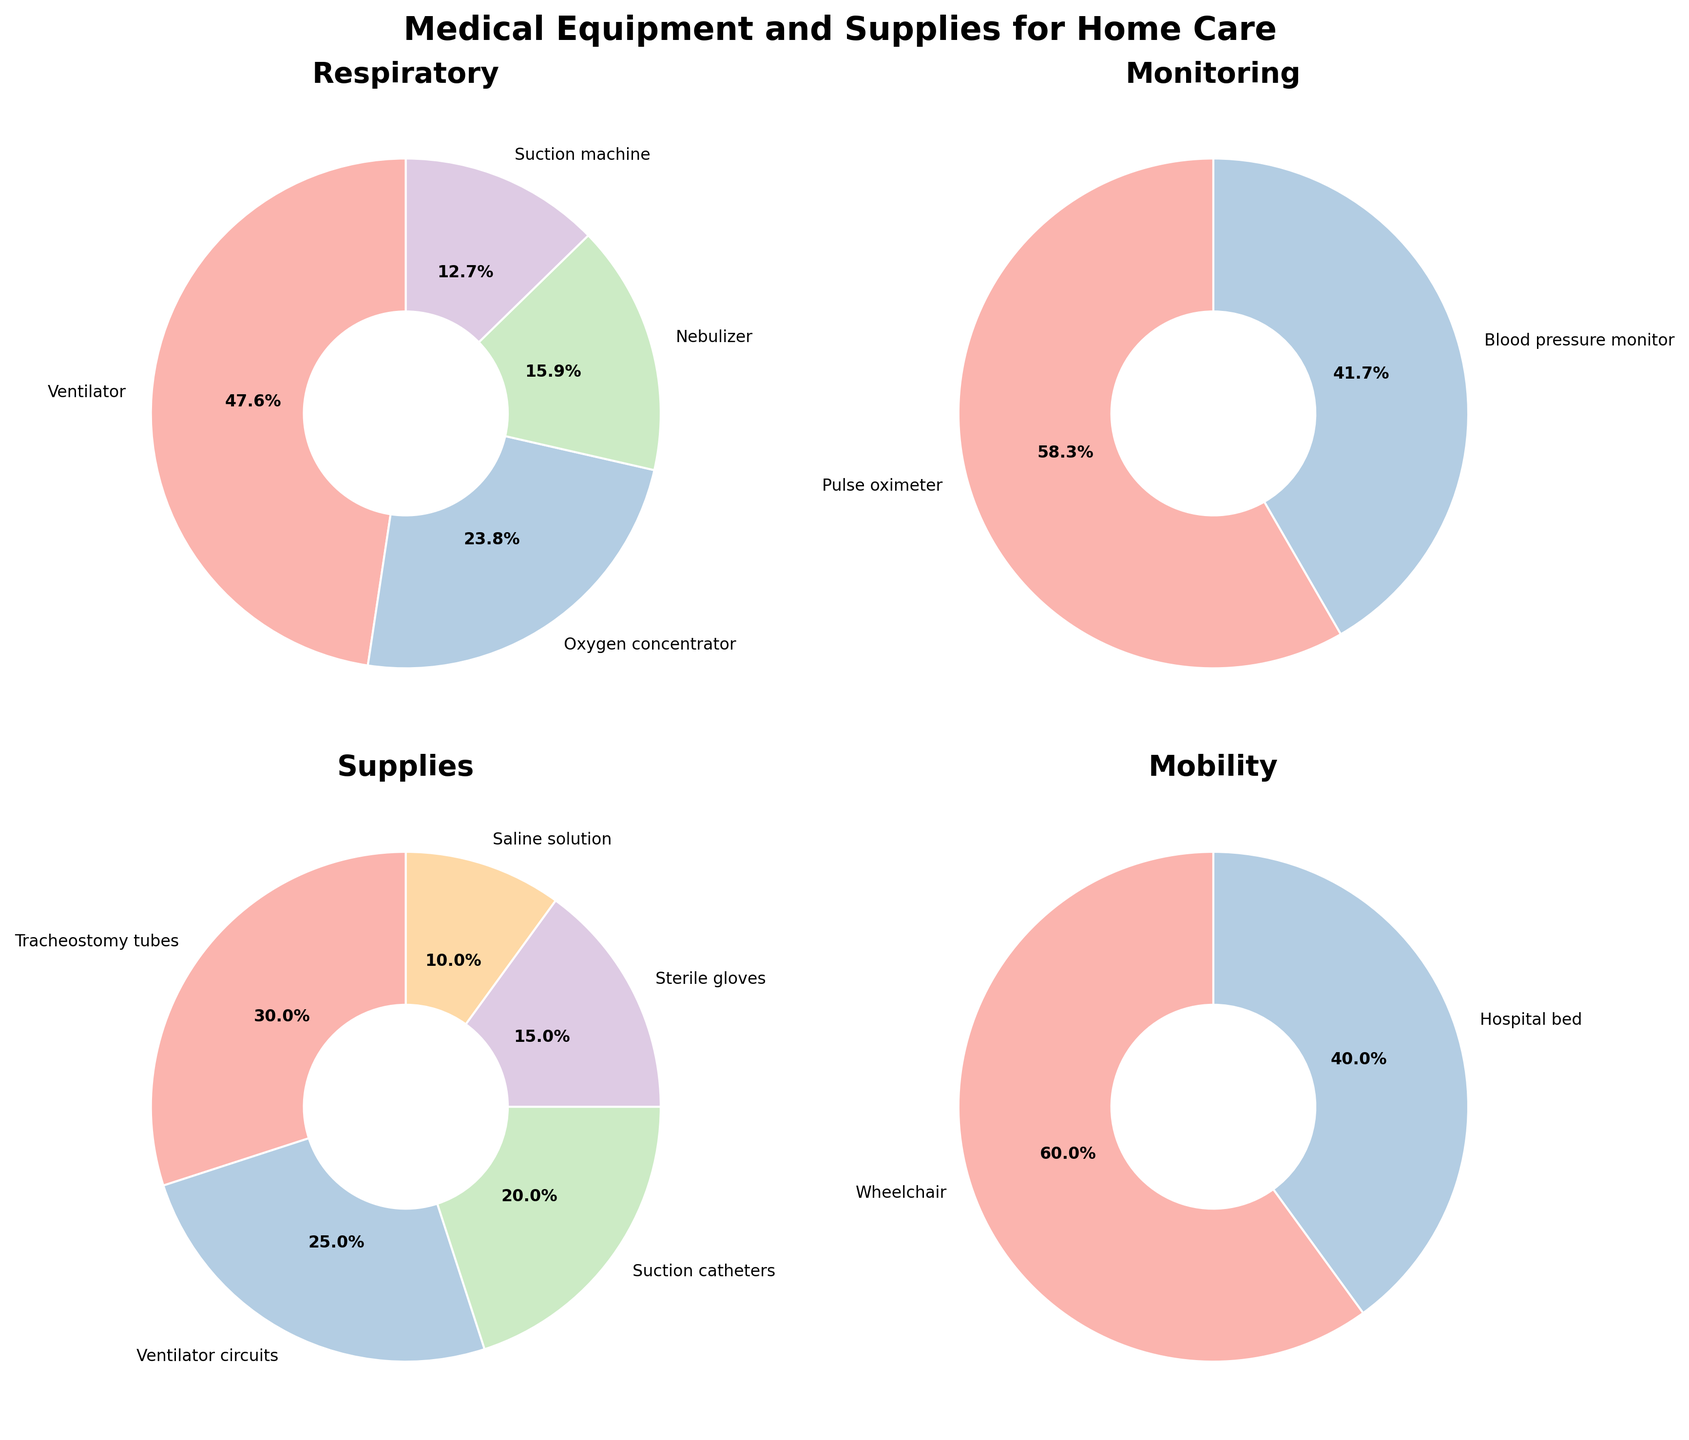What is the title of the entire figure? The title of the entire figure is written at the top and says "Medical Equipment and Supplies for Home Care".
Answer: Medical Equipment and Supplies for Home Care How many pie charts are there in the figure? There are visual segments in the layout showing the different categories; by counting them, you find there are four pie charts in total.
Answer: Four Which equipment has the largest percentage in the Respiratory category? In the Respiratory category, the Ventilator has the largest percentage, indicated by the biggest section of the pie chart and labeled with its percentage.
Answer: Ventilator What's the combined percentage of the Pulse oximeter and Blood pressure monitor in the Monitoring category? In the Monitoring category, the percentages for Pulse oximeter and Blood pressure monitor are 7% and 5% respectively. Adding them together gives 7% + 5% = 12%.
Answer: 12% Which has a greater percentage, a Wheelchair or a Hospital bed? In the Mobility category, the Wheelchair section is larger and labeled with a percentage of 3%, whereas the Hospital bed is labeled with 2%.
Answer: Wheelchair What percent of the Supplies category is composed of Suction catheters? Looking at the Supplies pie chart, the Suction catheters section is labeled with 4%.
Answer: 4% How much more percentage does the Ventilator have compared to the Tracheostomy tubes? In the Respiratory category, the Ventilator is labeled with 30%, and in the Supplies category, the Tracheostomy tubes are labeled with 6%. Subtracting them gives 30% - 6% = 24%.
Answer: 24% Which category has the highest number of individual equipment or supply items? By counting the items labeled in each pie chart, the Supplies category has five items, which is the most compared to other categories.
Answer: Supplies What is the average percentage per item in the Mobility category? The Mobility category has two items, the Wheelchair at 3% and the Hospital bed at 2%. The average is found by (3% + 2%) / 2 = 2.5%.
Answer: 2.5% Which respiratory equipment has the smallest section in its pie chart? In the Respiratory category, the section for the Suction machine is the smallest and is labeled with 8%.
Answer: Suction machine 